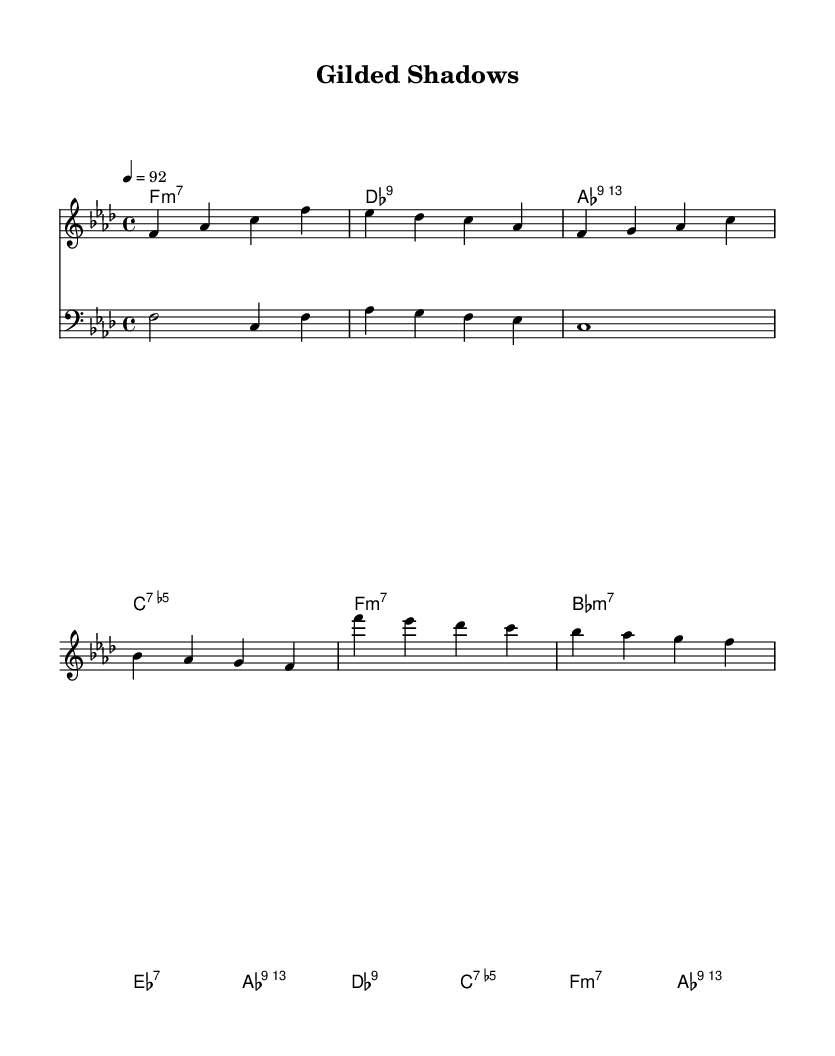What is the key signature of this music? The key signature indicates F minor, which is characterized by four flats (B, E, A, D). This is evident from the initial global settings in the code.
Answer: F minor What is the time signature of this music? The time signature is 4/4, which means there are four beats in each measure and the quarter note gets the beat. This is defined in the global settings of the code.
Answer: 4/4 What is the tempo marking for this piece? The tempo marking is 92 beats per minute. This is found in the global settings in the code where it states "4 = 92".
Answer: 92 How many measures are in the chorus section? The chorus consists of two measures, as indicated by the four-bar chorus section following the verse section in the piano part.
Answer: 2 What is the tonic chord for this piece? The tonic chord for this piece is F minor, as established in the chord changes where the first chord in the introduction and several sections is F minor.
Answer: F minor What type of chord is used in the first measure of the introduction? The first measure features an F minor 7 chord, as indicated by the chord names labeled in the introduction section of the code.
Answer: F:min7 What fusion genres can be identified in this piece? This piece can be identified as Jazz fusion incorporating hip-hop elements due to its blending of jazz harmonics with rhythmic elements that might come from hip-hop, such as the bass line and lyrical introspection.
Answer: Jazz fusion with hip-hop elements 